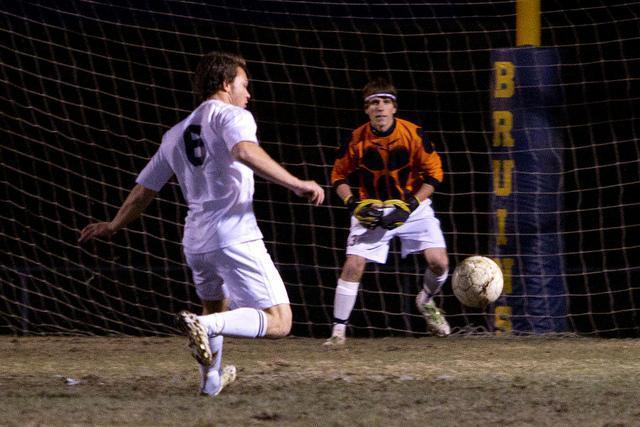How many people are in the photo?
Give a very brief answer. 2. 